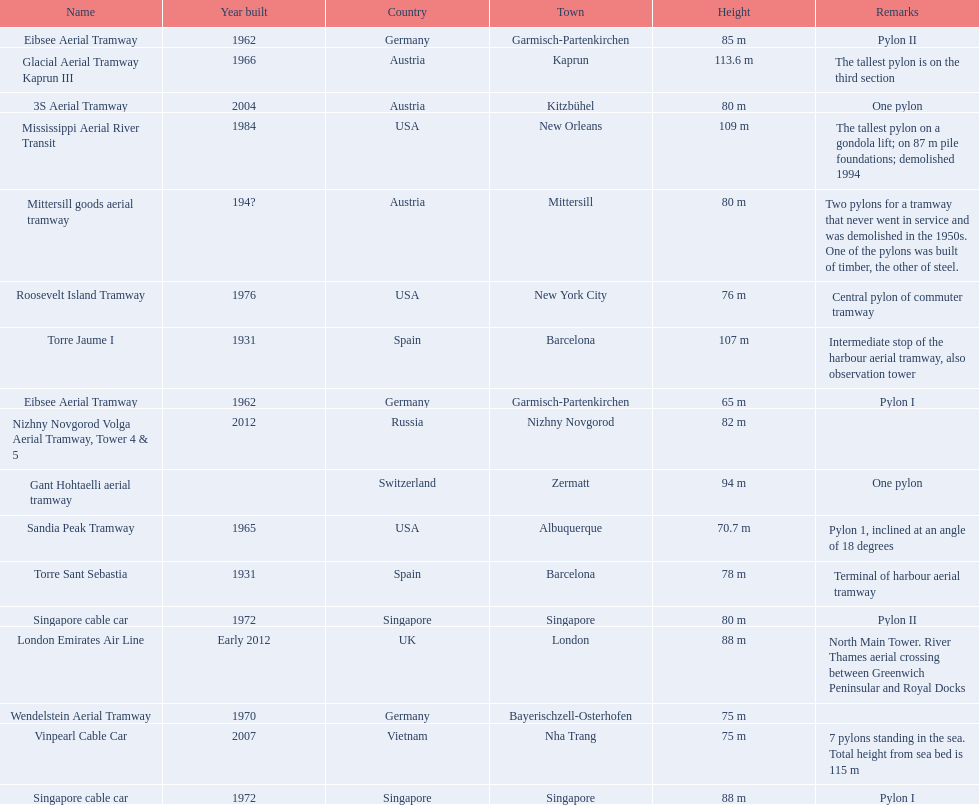Which aerial lifts are over 100 meters tall? Glacial Aerial Tramway Kaprun III, Mississippi Aerial River Transit, Torre Jaume I. Which of those was built last? Mississippi Aerial River Transit. And what is its total height? 109 m. 